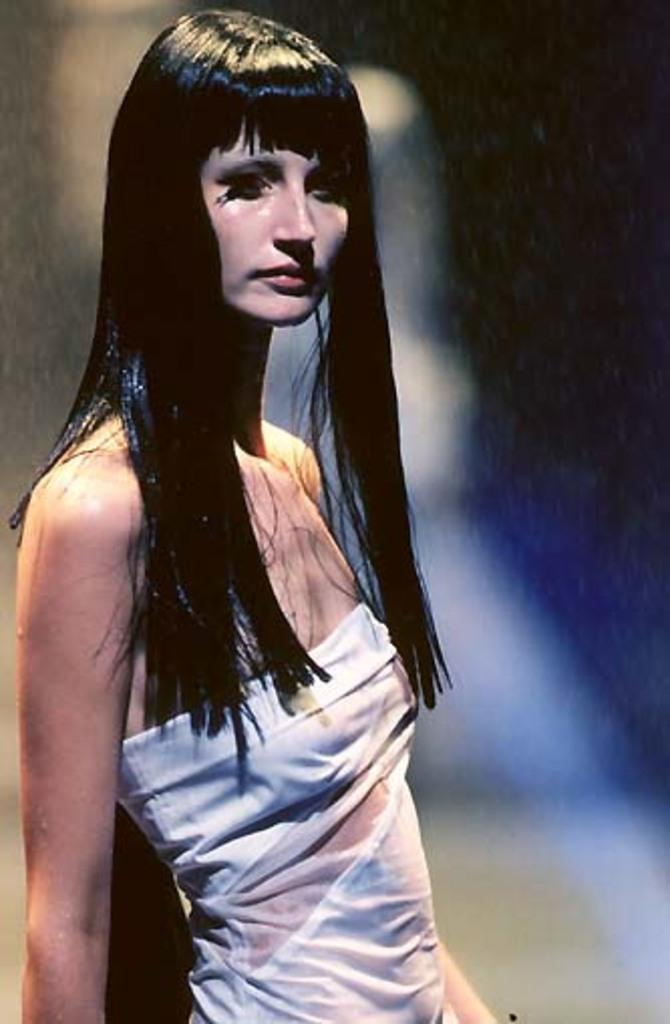Who is the main subject in the image? There is a lady in the image. What is the lady doing in the image? The lady is standing. What is the lady wearing in the image? The lady is wearing a white dress. What type of joke is the lady telling in the image? There is no joke being told in the image; the lady is simply standing and wearing a white dress. What kind of pie is the lady holding in the image? There is no pie present in the image. 